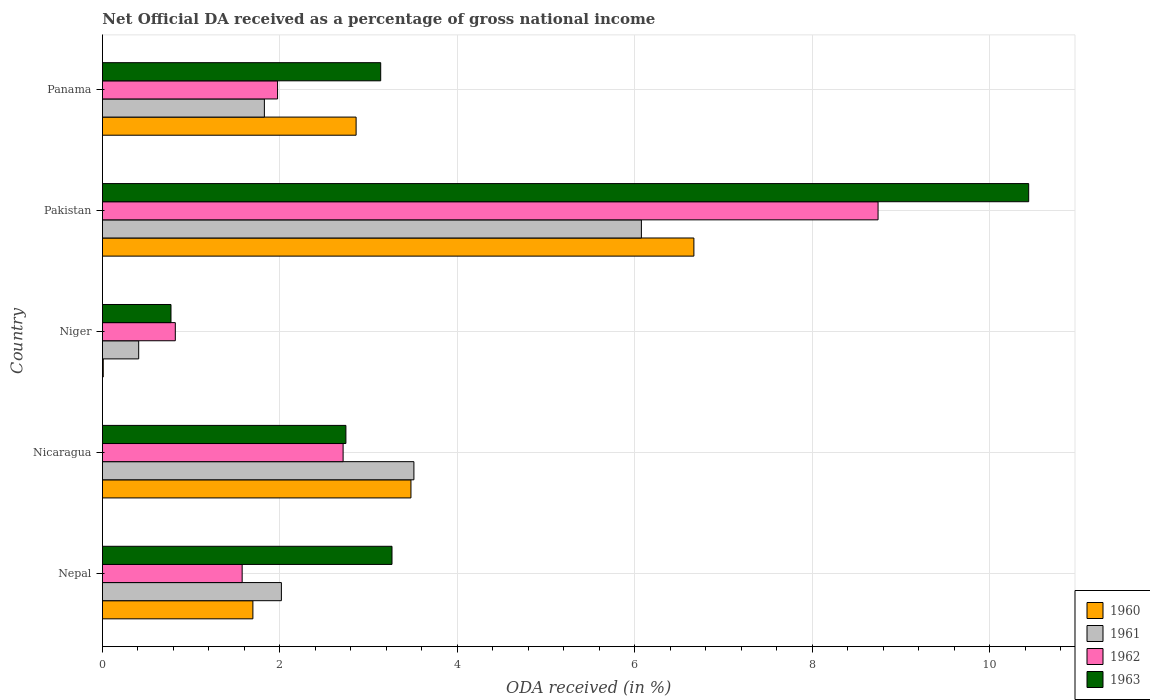How many bars are there on the 2nd tick from the top?
Your response must be concise. 4. What is the label of the 3rd group of bars from the top?
Provide a short and direct response. Niger. In how many cases, is the number of bars for a given country not equal to the number of legend labels?
Give a very brief answer. 0. What is the net official DA received in 1963 in Nepal?
Your response must be concise. 3.26. Across all countries, what is the maximum net official DA received in 1962?
Make the answer very short. 8.74. Across all countries, what is the minimum net official DA received in 1963?
Provide a short and direct response. 0.77. In which country was the net official DA received in 1961 maximum?
Offer a very short reply. Pakistan. In which country was the net official DA received in 1961 minimum?
Provide a short and direct response. Niger. What is the total net official DA received in 1960 in the graph?
Your answer should be very brief. 14.71. What is the difference between the net official DA received in 1961 in Nicaragua and that in Niger?
Your answer should be compact. 3.1. What is the difference between the net official DA received in 1961 in Panama and the net official DA received in 1960 in Nepal?
Make the answer very short. 0.13. What is the average net official DA received in 1962 per country?
Keep it short and to the point. 3.17. What is the difference between the net official DA received in 1960 and net official DA received in 1961 in Nicaragua?
Keep it short and to the point. -0.03. What is the ratio of the net official DA received in 1962 in Nicaragua to that in Niger?
Give a very brief answer. 3.3. What is the difference between the highest and the second highest net official DA received in 1963?
Ensure brevity in your answer.  7.18. What is the difference between the highest and the lowest net official DA received in 1963?
Your response must be concise. 9.67. Is the sum of the net official DA received in 1961 in Niger and Panama greater than the maximum net official DA received in 1963 across all countries?
Make the answer very short. No. What does the 4th bar from the top in Niger represents?
Your answer should be compact. 1960. Are all the bars in the graph horizontal?
Make the answer very short. Yes. How many countries are there in the graph?
Keep it short and to the point. 5. Are the values on the major ticks of X-axis written in scientific E-notation?
Give a very brief answer. No. Does the graph contain any zero values?
Provide a short and direct response. No. How are the legend labels stacked?
Your answer should be very brief. Vertical. What is the title of the graph?
Keep it short and to the point. Net Official DA received as a percentage of gross national income. Does "1973" appear as one of the legend labels in the graph?
Your answer should be compact. No. What is the label or title of the X-axis?
Give a very brief answer. ODA received (in %). What is the ODA received (in %) in 1960 in Nepal?
Provide a succinct answer. 1.7. What is the ODA received (in %) in 1961 in Nepal?
Provide a succinct answer. 2.02. What is the ODA received (in %) in 1962 in Nepal?
Offer a terse response. 1.57. What is the ODA received (in %) in 1963 in Nepal?
Your answer should be compact. 3.26. What is the ODA received (in %) in 1960 in Nicaragua?
Your answer should be very brief. 3.48. What is the ODA received (in %) of 1961 in Nicaragua?
Provide a succinct answer. 3.51. What is the ODA received (in %) in 1962 in Nicaragua?
Offer a terse response. 2.71. What is the ODA received (in %) in 1963 in Nicaragua?
Offer a terse response. 2.74. What is the ODA received (in %) of 1960 in Niger?
Offer a terse response. 0.01. What is the ODA received (in %) in 1961 in Niger?
Your answer should be compact. 0.41. What is the ODA received (in %) of 1962 in Niger?
Make the answer very short. 0.82. What is the ODA received (in %) of 1963 in Niger?
Give a very brief answer. 0.77. What is the ODA received (in %) of 1960 in Pakistan?
Provide a short and direct response. 6.67. What is the ODA received (in %) in 1961 in Pakistan?
Provide a succinct answer. 6.08. What is the ODA received (in %) of 1962 in Pakistan?
Your answer should be compact. 8.74. What is the ODA received (in %) of 1963 in Pakistan?
Your answer should be very brief. 10.44. What is the ODA received (in %) of 1960 in Panama?
Give a very brief answer. 2.86. What is the ODA received (in %) of 1961 in Panama?
Offer a very short reply. 1.83. What is the ODA received (in %) of 1962 in Panama?
Give a very brief answer. 1.97. What is the ODA received (in %) in 1963 in Panama?
Your answer should be compact. 3.14. Across all countries, what is the maximum ODA received (in %) in 1960?
Ensure brevity in your answer.  6.67. Across all countries, what is the maximum ODA received (in %) in 1961?
Keep it short and to the point. 6.08. Across all countries, what is the maximum ODA received (in %) in 1962?
Offer a terse response. 8.74. Across all countries, what is the maximum ODA received (in %) of 1963?
Ensure brevity in your answer.  10.44. Across all countries, what is the minimum ODA received (in %) of 1960?
Offer a terse response. 0.01. Across all countries, what is the minimum ODA received (in %) in 1961?
Your answer should be compact. 0.41. Across all countries, what is the minimum ODA received (in %) of 1962?
Offer a very short reply. 0.82. Across all countries, what is the minimum ODA received (in %) of 1963?
Provide a succinct answer. 0.77. What is the total ODA received (in %) of 1960 in the graph?
Your response must be concise. 14.71. What is the total ODA received (in %) of 1961 in the graph?
Offer a terse response. 13.84. What is the total ODA received (in %) of 1962 in the graph?
Offer a very short reply. 15.83. What is the total ODA received (in %) in 1963 in the graph?
Your answer should be compact. 20.36. What is the difference between the ODA received (in %) of 1960 in Nepal and that in Nicaragua?
Your answer should be compact. -1.78. What is the difference between the ODA received (in %) of 1961 in Nepal and that in Nicaragua?
Provide a succinct answer. -1.49. What is the difference between the ODA received (in %) of 1962 in Nepal and that in Nicaragua?
Your answer should be compact. -1.14. What is the difference between the ODA received (in %) of 1963 in Nepal and that in Nicaragua?
Your answer should be compact. 0.52. What is the difference between the ODA received (in %) of 1960 in Nepal and that in Niger?
Provide a succinct answer. 1.69. What is the difference between the ODA received (in %) in 1961 in Nepal and that in Niger?
Offer a very short reply. 1.61. What is the difference between the ODA received (in %) of 1962 in Nepal and that in Niger?
Provide a succinct answer. 0.75. What is the difference between the ODA received (in %) of 1963 in Nepal and that in Niger?
Your response must be concise. 2.49. What is the difference between the ODA received (in %) of 1960 in Nepal and that in Pakistan?
Provide a succinct answer. -4.97. What is the difference between the ODA received (in %) in 1961 in Nepal and that in Pakistan?
Give a very brief answer. -4.06. What is the difference between the ODA received (in %) in 1962 in Nepal and that in Pakistan?
Give a very brief answer. -7.17. What is the difference between the ODA received (in %) in 1963 in Nepal and that in Pakistan?
Give a very brief answer. -7.18. What is the difference between the ODA received (in %) in 1960 in Nepal and that in Panama?
Your answer should be very brief. -1.16. What is the difference between the ODA received (in %) in 1961 in Nepal and that in Panama?
Offer a terse response. 0.19. What is the difference between the ODA received (in %) in 1962 in Nepal and that in Panama?
Provide a short and direct response. -0.4. What is the difference between the ODA received (in %) in 1963 in Nepal and that in Panama?
Your answer should be very brief. 0.13. What is the difference between the ODA received (in %) of 1960 in Nicaragua and that in Niger?
Make the answer very short. 3.47. What is the difference between the ODA received (in %) in 1961 in Nicaragua and that in Niger?
Your answer should be very brief. 3.1. What is the difference between the ODA received (in %) in 1962 in Nicaragua and that in Niger?
Keep it short and to the point. 1.89. What is the difference between the ODA received (in %) of 1963 in Nicaragua and that in Niger?
Give a very brief answer. 1.97. What is the difference between the ODA received (in %) of 1960 in Nicaragua and that in Pakistan?
Give a very brief answer. -3.19. What is the difference between the ODA received (in %) in 1961 in Nicaragua and that in Pakistan?
Your answer should be very brief. -2.56. What is the difference between the ODA received (in %) in 1962 in Nicaragua and that in Pakistan?
Offer a terse response. -6.03. What is the difference between the ODA received (in %) in 1963 in Nicaragua and that in Pakistan?
Your response must be concise. -7.7. What is the difference between the ODA received (in %) in 1960 in Nicaragua and that in Panama?
Ensure brevity in your answer.  0.62. What is the difference between the ODA received (in %) in 1961 in Nicaragua and that in Panama?
Keep it short and to the point. 1.69. What is the difference between the ODA received (in %) in 1962 in Nicaragua and that in Panama?
Make the answer very short. 0.74. What is the difference between the ODA received (in %) of 1963 in Nicaragua and that in Panama?
Offer a terse response. -0.39. What is the difference between the ODA received (in %) of 1960 in Niger and that in Pakistan?
Give a very brief answer. -6.66. What is the difference between the ODA received (in %) of 1961 in Niger and that in Pakistan?
Offer a very short reply. -5.67. What is the difference between the ODA received (in %) of 1962 in Niger and that in Pakistan?
Provide a short and direct response. -7.92. What is the difference between the ODA received (in %) in 1963 in Niger and that in Pakistan?
Your response must be concise. -9.67. What is the difference between the ODA received (in %) in 1960 in Niger and that in Panama?
Offer a very short reply. -2.85. What is the difference between the ODA received (in %) in 1961 in Niger and that in Panama?
Provide a succinct answer. -1.42. What is the difference between the ODA received (in %) in 1962 in Niger and that in Panama?
Offer a very short reply. -1.15. What is the difference between the ODA received (in %) of 1963 in Niger and that in Panama?
Provide a short and direct response. -2.36. What is the difference between the ODA received (in %) in 1960 in Pakistan and that in Panama?
Provide a short and direct response. 3.81. What is the difference between the ODA received (in %) of 1961 in Pakistan and that in Panama?
Your response must be concise. 4.25. What is the difference between the ODA received (in %) in 1962 in Pakistan and that in Panama?
Your answer should be very brief. 6.77. What is the difference between the ODA received (in %) of 1963 in Pakistan and that in Panama?
Your response must be concise. 7.3. What is the difference between the ODA received (in %) in 1960 in Nepal and the ODA received (in %) in 1961 in Nicaragua?
Provide a succinct answer. -1.82. What is the difference between the ODA received (in %) in 1960 in Nepal and the ODA received (in %) in 1962 in Nicaragua?
Keep it short and to the point. -1.02. What is the difference between the ODA received (in %) of 1960 in Nepal and the ODA received (in %) of 1963 in Nicaragua?
Offer a very short reply. -1.05. What is the difference between the ODA received (in %) of 1961 in Nepal and the ODA received (in %) of 1962 in Nicaragua?
Your answer should be compact. -0.7. What is the difference between the ODA received (in %) of 1961 in Nepal and the ODA received (in %) of 1963 in Nicaragua?
Provide a short and direct response. -0.73. What is the difference between the ODA received (in %) of 1962 in Nepal and the ODA received (in %) of 1963 in Nicaragua?
Make the answer very short. -1.17. What is the difference between the ODA received (in %) of 1960 in Nepal and the ODA received (in %) of 1961 in Niger?
Ensure brevity in your answer.  1.29. What is the difference between the ODA received (in %) in 1960 in Nepal and the ODA received (in %) in 1962 in Niger?
Give a very brief answer. 0.87. What is the difference between the ODA received (in %) in 1960 in Nepal and the ODA received (in %) in 1963 in Niger?
Give a very brief answer. 0.92. What is the difference between the ODA received (in %) in 1961 in Nepal and the ODA received (in %) in 1962 in Niger?
Make the answer very short. 1.2. What is the difference between the ODA received (in %) in 1961 in Nepal and the ODA received (in %) in 1963 in Niger?
Make the answer very short. 1.24. What is the difference between the ODA received (in %) in 1962 in Nepal and the ODA received (in %) in 1963 in Niger?
Your answer should be very brief. 0.8. What is the difference between the ODA received (in %) in 1960 in Nepal and the ODA received (in %) in 1961 in Pakistan?
Your response must be concise. -4.38. What is the difference between the ODA received (in %) in 1960 in Nepal and the ODA received (in %) in 1962 in Pakistan?
Ensure brevity in your answer.  -7.05. What is the difference between the ODA received (in %) in 1960 in Nepal and the ODA received (in %) in 1963 in Pakistan?
Make the answer very short. -8.75. What is the difference between the ODA received (in %) in 1961 in Nepal and the ODA received (in %) in 1962 in Pakistan?
Make the answer very short. -6.73. What is the difference between the ODA received (in %) of 1961 in Nepal and the ODA received (in %) of 1963 in Pakistan?
Make the answer very short. -8.42. What is the difference between the ODA received (in %) in 1962 in Nepal and the ODA received (in %) in 1963 in Pakistan?
Your response must be concise. -8.87. What is the difference between the ODA received (in %) in 1960 in Nepal and the ODA received (in %) in 1961 in Panama?
Your answer should be very brief. -0.13. What is the difference between the ODA received (in %) of 1960 in Nepal and the ODA received (in %) of 1962 in Panama?
Provide a succinct answer. -0.28. What is the difference between the ODA received (in %) of 1960 in Nepal and the ODA received (in %) of 1963 in Panama?
Offer a very short reply. -1.44. What is the difference between the ODA received (in %) of 1961 in Nepal and the ODA received (in %) of 1962 in Panama?
Make the answer very short. 0.04. What is the difference between the ODA received (in %) of 1961 in Nepal and the ODA received (in %) of 1963 in Panama?
Your answer should be very brief. -1.12. What is the difference between the ODA received (in %) of 1962 in Nepal and the ODA received (in %) of 1963 in Panama?
Ensure brevity in your answer.  -1.56. What is the difference between the ODA received (in %) in 1960 in Nicaragua and the ODA received (in %) in 1961 in Niger?
Provide a succinct answer. 3.07. What is the difference between the ODA received (in %) in 1960 in Nicaragua and the ODA received (in %) in 1962 in Niger?
Provide a short and direct response. 2.66. What is the difference between the ODA received (in %) in 1960 in Nicaragua and the ODA received (in %) in 1963 in Niger?
Ensure brevity in your answer.  2.71. What is the difference between the ODA received (in %) of 1961 in Nicaragua and the ODA received (in %) of 1962 in Niger?
Your answer should be very brief. 2.69. What is the difference between the ODA received (in %) of 1961 in Nicaragua and the ODA received (in %) of 1963 in Niger?
Make the answer very short. 2.74. What is the difference between the ODA received (in %) of 1962 in Nicaragua and the ODA received (in %) of 1963 in Niger?
Provide a succinct answer. 1.94. What is the difference between the ODA received (in %) of 1960 in Nicaragua and the ODA received (in %) of 1961 in Pakistan?
Provide a succinct answer. -2.6. What is the difference between the ODA received (in %) of 1960 in Nicaragua and the ODA received (in %) of 1962 in Pakistan?
Offer a very short reply. -5.27. What is the difference between the ODA received (in %) of 1960 in Nicaragua and the ODA received (in %) of 1963 in Pakistan?
Offer a terse response. -6.96. What is the difference between the ODA received (in %) of 1961 in Nicaragua and the ODA received (in %) of 1962 in Pakistan?
Ensure brevity in your answer.  -5.23. What is the difference between the ODA received (in %) of 1961 in Nicaragua and the ODA received (in %) of 1963 in Pakistan?
Provide a short and direct response. -6.93. What is the difference between the ODA received (in %) of 1962 in Nicaragua and the ODA received (in %) of 1963 in Pakistan?
Your answer should be very brief. -7.73. What is the difference between the ODA received (in %) in 1960 in Nicaragua and the ODA received (in %) in 1961 in Panama?
Offer a very short reply. 1.65. What is the difference between the ODA received (in %) of 1960 in Nicaragua and the ODA received (in %) of 1962 in Panama?
Your answer should be very brief. 1.5. What is the difference between the ODA received (in %) in 1960 in Nicaragua and the ODA received (in %) in 1963 in Panama?
Provide a succinct answer. 0.34. What is the difference between the ODA received (in %) in 1961 in Nicaragua and the ODA received (in %) in 1962 in Panama?
Keep it short and to the point. 1.54. What is the difference between the ODA received (in %) of 1961 in Nicaragua and the ODA received (in %) of 1963 in Panama?
Provide a short and direct response. 0.37. What is the difference between the ODA received (in %) in 1962 in Nicaragua and the ODA received (in %) in 1963 in Panama?
Give a very brief answer. -0.42. What is the difference between the ODA received (in %) in 1960 in Niger and the ODA received (in %) in 1961 in Pakistan?
Your response must be concise. -6.07. What is the difference between the ODA received (in %) of 1960 in Niger and the ODA received (in %) of 1962 in Pakistan?
Ensure brevity in your answer.  -8.73. What is the difference between the ODA received (in %) of 1960 in Niger and the ODA received (in %) of 1963 in Pakistan?
Your response must be concise. -10.43. What is the difference between the ODA received (in %) in 1961 in Niger and the ODA received (in %) in 1962 in Pakistan?
Offer a terse response. -8.34. What is the difference between the ODA received (in %) of 1961 in Niger and the ODA received (in %) of 1963 in Pakistan?
Offer a very short reply. -10.03. What is the difference between the ODA received (in %) in 1962 in Niger and the ODA received (in %) in 1963 in Pakistan?
Offer a terse response. -9.62. What is the difference between the ODA received (in %) in 1960 in Niger and the ODA received (in %) in 1961 in Panama?
Make the answer very short. -1.82. What is the difference between the ODA received (in %) in 1960 in Niger and the ODA received (in %) in 1962 in Panama?
Your answer should be compact. -1.97. What is the difference between the ODA received (in %) in 1960 in Niger and the ODA received (in %) in 1963 in Panama?
Offer a terse response. -3.13. What is the difference between the ODA received (in %) of 1961 in Niger and the ODA received (in %) of 1962 in Panama?
Keep it short and to the point. -1.57. What is the difference between the ODA received (in %) of 1961 in Niger and the ODA received (in %) of 1963 in Panama?
Provide a short and direct response. -2.73. What is the difference between the ODA received (in %) of 1962 in Niger and the ODA received (in %) of 1963 in Panama?
Your response must be concise. -2.32. What is the difference between the ODA received (in %) in 1960 in Pakistan and the ODA received (in %) in 1961 in Panama?
Give a very brief answer. 4.84. What is the difference between the ODA received (in %) of 1960 in Pakistan and the ODA received (in %) of 1962 in Panama?
Ensure brevity in your answer.  4.69. What is the difference between the ODA received (in %) of 1960 in Pakistan and the ODA received (in %) of 1963 in Panama?
Your answer should be very brief. 3.53. What is the difference between the ODA received (in %) of 1961 in Pakistan and the ODA received (in %) of 1962 in Panama?
Make the answer very short. 4.1. What is the difference between the ODA received (in %) of 1961 in Pakistan and the ODA received (in %) of 1963 in Panama?
Make the answer very short. 2.94. What is the difference between the ODA received (in %) in 1962 in Pakistan and the ODA received (in %) in 1963 in Panama?
Give a very brief answer. 5.61. What is the average ODA received (in %) of 1960 per country?
Offer a very short reply. 2.94. What is the average ODA received (in %) of 1961 per country?
Provide a succinct answer. 2.77. What is the average ODA received (in %) of 1962 per country?
Provide a short and direct response. 3.17. What is the average ODA received (in %) in 1963 per country?
Provide a succinct answer. 4.07. What is the difference between the ODA received (in %) of 1960 and ODA received (in %) of 1961 in Nepal?
Provide a succinct answer. -0.32. What is the difference between the ODA received (in %) of 1960 and ODA received (in %) of 1962 in Nepal?
Offer a terse response. 0.12. What is the difference between the ODA received (in %) in 1960 and ODA received (in %) in 1963 in Nepal?
Your answer should be compact. -1.57. What is the difference between the ODA received (in %) in 1961 and ODA received (in %) in 1962 in Nepal?
Provide a short and direct response. 0.44. What is the difference between the ODA received (in %) of 1961 and ODA received (in %) of 1963 in Nepal?
Ensure brevity in your answer.  -1.25. What is the difference between the ODA received (in %) in 1962 and ODA received (in %) in 1963 in Nepal?
Offer a terse response. -1.69. What is the difference between the ODA received (in %) in 1960 and ODA received (in %) in 1961 in Nicaragua?
Provide a succinct answer. -0.03. What is the difference between the ODA received (in %) of 1960 and ODA received (in %) of 1962 in Nicaragua?
Offer a terse response. 0.76. What is the difference between the ODA received (in %) in 1960 and ODA received (in %) in 1963 in Nicaragua?
Your response must be concise. 0.73. What is the difference between the ODA received (in %) in 1961 and ODA received (in %) in 1962 in Nicaragua?
Give a very brief answer. 0.8. What is the difference between the ODA received (in %) in 1961 and ODA received (in %) in 1963 in Nicaragua?
Make the answer very short. 0.77. What is the difference between the ODA received (in %) in 1962 and ODA received (in %) in 1963 in Nicaragua?
Keep it short and to the point. -0.03. What is the difference between the ODA received (in %) of 1960 and ODA received (in %) of 1961 in Niger?
Your response must be concise. -0.4. What is the difference between the ODA received (in %) of 1960 and ODA received (in %) of 1962 in Niger?
Your answer should be compact. -0.81. What is the difference between the ODA received (in %) of 1960 and ODA received (in %) of 1963 in Niger?
Keep it short and to the point. -0.76. What is the difference between the ODA received (in %) in 1961 and ODA received (in %) in 1962 in Niger?
Make the answer very short. -0.41. What is the difference between the ODA received (in %) in 1961 and ODA received (in %) in 1963 in Niger?
Make the answer very short. -0.36. What is the difference between the ODA received (in %) of 1962 and ODA received (in %) of 1963 in Niger?
Your answer should be compact. 0.05. What is the difference between the ODA received (in %) of 1960 and ODA received (in %) of 1961 in Pakistan?
Your response must be concise. 0.59. What is the difference between the ODA received (in %) of 1960 and ODA received (in %) of 1962 in Pakistan?
Give a very brief answer. -2.08. What is the difference between the ODA received (in %) of 1960 and ODA received (in %) of 1963 in Pakistan?
Offer a terse response. -3.77. What is the difference between the ODA received (in %) of 1961 and ODA received (in %) of 1962 in Pakistan?
Offer a terse response. -2.67. What is the difference between the ODA received (in %) in 1961 and ODA received (in %) in 1963 in Pakistan?
Give a very brief answer. -4.37. What is the difference between the ODA received (in %) of 1962 and ODA received (in %) of 1963 in Pakistan?
Give a very brief answer. -1.7. What is the difference between the ODA received (in %) of 1960 and ODA received (in %) of 1961 in Panama?
Offer a very short reply. 1.03. What is the difference between the ODA received (in %) in 1960 and ODA received (in %) in 1962 in Panama?
Your answer should be very brief. 0.89. What is the difference between the ODA received (in %) in 1960 and ODA received (in %) in 1963 in Panama?
Provide a short and direct response. -0.28. What is the difference between the ODA received (in %) of 1961 and ODA received (in %) of 1962 in Panama?
Keep it short and to the point. -0.15. What is the difference between the ODA received (in %) of 1961 and ODA received (in %) of 1963 in Panama?
Make the answer very short. -1.31. What is the difference between the ODA received (in %) in 1962 and ODA received (in %) in 1963 in Panama?
Provide a short and direct response. -1.16. What is the ratio of the ODA received (in %) of 1960 in Nepal to that in Nicaragua?
Offer a very short reply. 0.49. What is the ratio of the ODA received (in %) in 1961 in Nepal to that in Nicaragua?
Make the answer very short. 0.57. What is the ratio of the ODA received (in %) in 1962 in Nepal to that in Nicaragua?
Your response must be concise. 0.58. What is the ratio of the ODA received (in %) in 1963 in Nepal to that in Nicaragua?
Ensure brevity in your answer.  1.19. What is the ratio of the ODA received (in %) in 1960 in Nepal to that in Niger?
Offer a terse response. 191.09. What is the ratio of the ODA received (in %) of 1961 in Nepal to that in Niger?
Offer a very short reply. 4.94. What is the ratio of the ODA received (in %) in 1962 in Nepal to that in Niger?
Provide a short and direct response. 1.92. What is the ratio of the ODA received (in %) of 1963 in Nepal to that in Niger?
Offer a very short reply. 4.23. What is the ratio of the ODA received (in %) in 1960 in Nepal to that in Pakistan?
Your answer should be very brief. 0.25. What is the ratio of the ODA received (in %) in 1961 in Nepal to that in Pakistan?
Keep it short and to the point. 0.33. What is the ratio of the ODA received (in %) of 1962 in Nepal to that in Pakistan?
Your response must be concise. 0.18. What is the ratio of the ODA received (in %) in 1963 in Nepal to that in Pakistan?
Give a very brief answer. 0.31. What is the ratio of the ODA received (in %) of 1960 in Nepal to that in Panama?
Offer a terse response. 0.59. What is the ratio of the ODA received (in %) of 1961 in Nepal to that in Panama?
Your response must be concise. 1.11. What is the ratio of the ODA received (in %) in 1962 in Nepal to that in Panama?
Give a very brief answer. 0.8. What is the ratio of the ODA received (in %) of 1963 in Nepal to that in Panama?
Provide a succinct answer. 1.04. What is the ratio of the ODA received (in %) of 1960 in Nicaragua to that in Niger?
Ensure brevity in your answer.  391.87. What is the ratio of the ODA received (in %) in 1961 in Nicaragua to that in Niger?
Offer a very short reply. 8.6. What is the ratio of the ODA received (in %) in 1962 in Nicaragua to that in Niger?
Provide a short and direct response. 3.3. What is the ratio of the ODA received (in %) of 1963 in Nicaragua to that in Niger?
Make the answer very short. 3.55. What is the ratio of the ODA received (in %) in 1960 in Nicaragua to that in Pakistan?
Your response must be concise. 0.52. What is the ratio of the ODA received (in %) in 1961 in Nicaragua to that in Pakistan?
Provide a short and direct response. 0.58. What is the ratio of the ODA received (in %) in 1962 in Nicaragua to that in Pakistan?
Offer a terse response. 0.31. What is the ratio of the ODA received (in %) in 1963 in Nicaragua to that in Pakistan?
Your answer should be compact. 0.26. What is the ratio of the ODA received (in %) of 1960 in Nicaragua to that in Panama?
Give a very brief answer. 1.22. What is the ratio of the ODA received (in %) in 1961 in Nicaragua to that in Panama?
Ensure brevity in your answer.  1.92. What is the ratio of the ODA received (in %) of 1962 in Nicaragua to that in Panama?
Give a very brief answer. 1.37. What is the ratio of the ODA received (in %) of 1963 in Nicaragua to that in Panama?
Provide a short and direct response. 0.87. What is the ratio of the ODA received (in %) in 1960 in Niger to that in Pakistan?
Your response must be concise. 0. What is the ratio of the ODA received (in %) of 1961 in Niger to that in Pakistan?
Your answer should be very brief. 0.07. What is the ratio of the ODA received (in %) of 1962 in Niger to that in Pakistan?
Your answer should be very brief. 0.09. What is the ratio of the ODA received (in %) of 1963 in Niger to that in Pakistan?
Keep it short and to the point. 0.07. What is the ratio of the ODA received (in %) of 1960 in Niger to that in Panama?
Your response must be concise. 0. What is the ratio of the ODA received (in %) in 1961 in Niger to that in Panama?
Your response must be concise. 0.22. What is the ratio of the ODA received (in %) of 1962 in Niger to that in Panama?
Keep it short and to the point. 0.42. What is the ratio of the ODA received (in %) of 1963 in Niger to that in Panama?
Your response must be concise. 0.25. What is the ratio of the ODA received (in %) in 1960 in Pakistan to that in Panama?
Your answer should be very brief. 2.33. What is the ratio of the ODA received (in %) of 1961 in Pakistan to that in Panama?
Offer a terse response. 3.33. What is the ratio of the ODA received (in %) of 1962 in Pakistan to that in Panama?
Offer a very short reply. 4.43. What is the ratio of the ODA received (in %) of 1963 in Pakistan to that in Panama?
Your response must be concise. 3.33. What is the difference between the highest and the second highest ODA received (in %) of 1960?
Offer a very short reply. 3.19. What is the difference between the highest and the second highest ODA received (in %) of 1961?
Offer a terse response. 2.56. What is the difference between the highest and the second highest ODA received (in %) of 1962?
Your answer should be compact. 6.03. What is the difference between the highest and the second highest ODA received (in %) of 1963?
Make the answer very short. 7.18. What is the difference between the highest and the lowest ODA received (in %) of 1960?
Make the answer very short. 6.66. What is the difference between the highest and the lowest ODA received (in %) in 1961?
Make the answer very short. 5.67. What is the difference between the highest and the lowest ODA received (in %) in 1962?
Offer a terse response. 7.92. What is the difference between the highest and the lowest ODA received (in %) in 1963?
Ensure brevity in your answer.  9.67. 